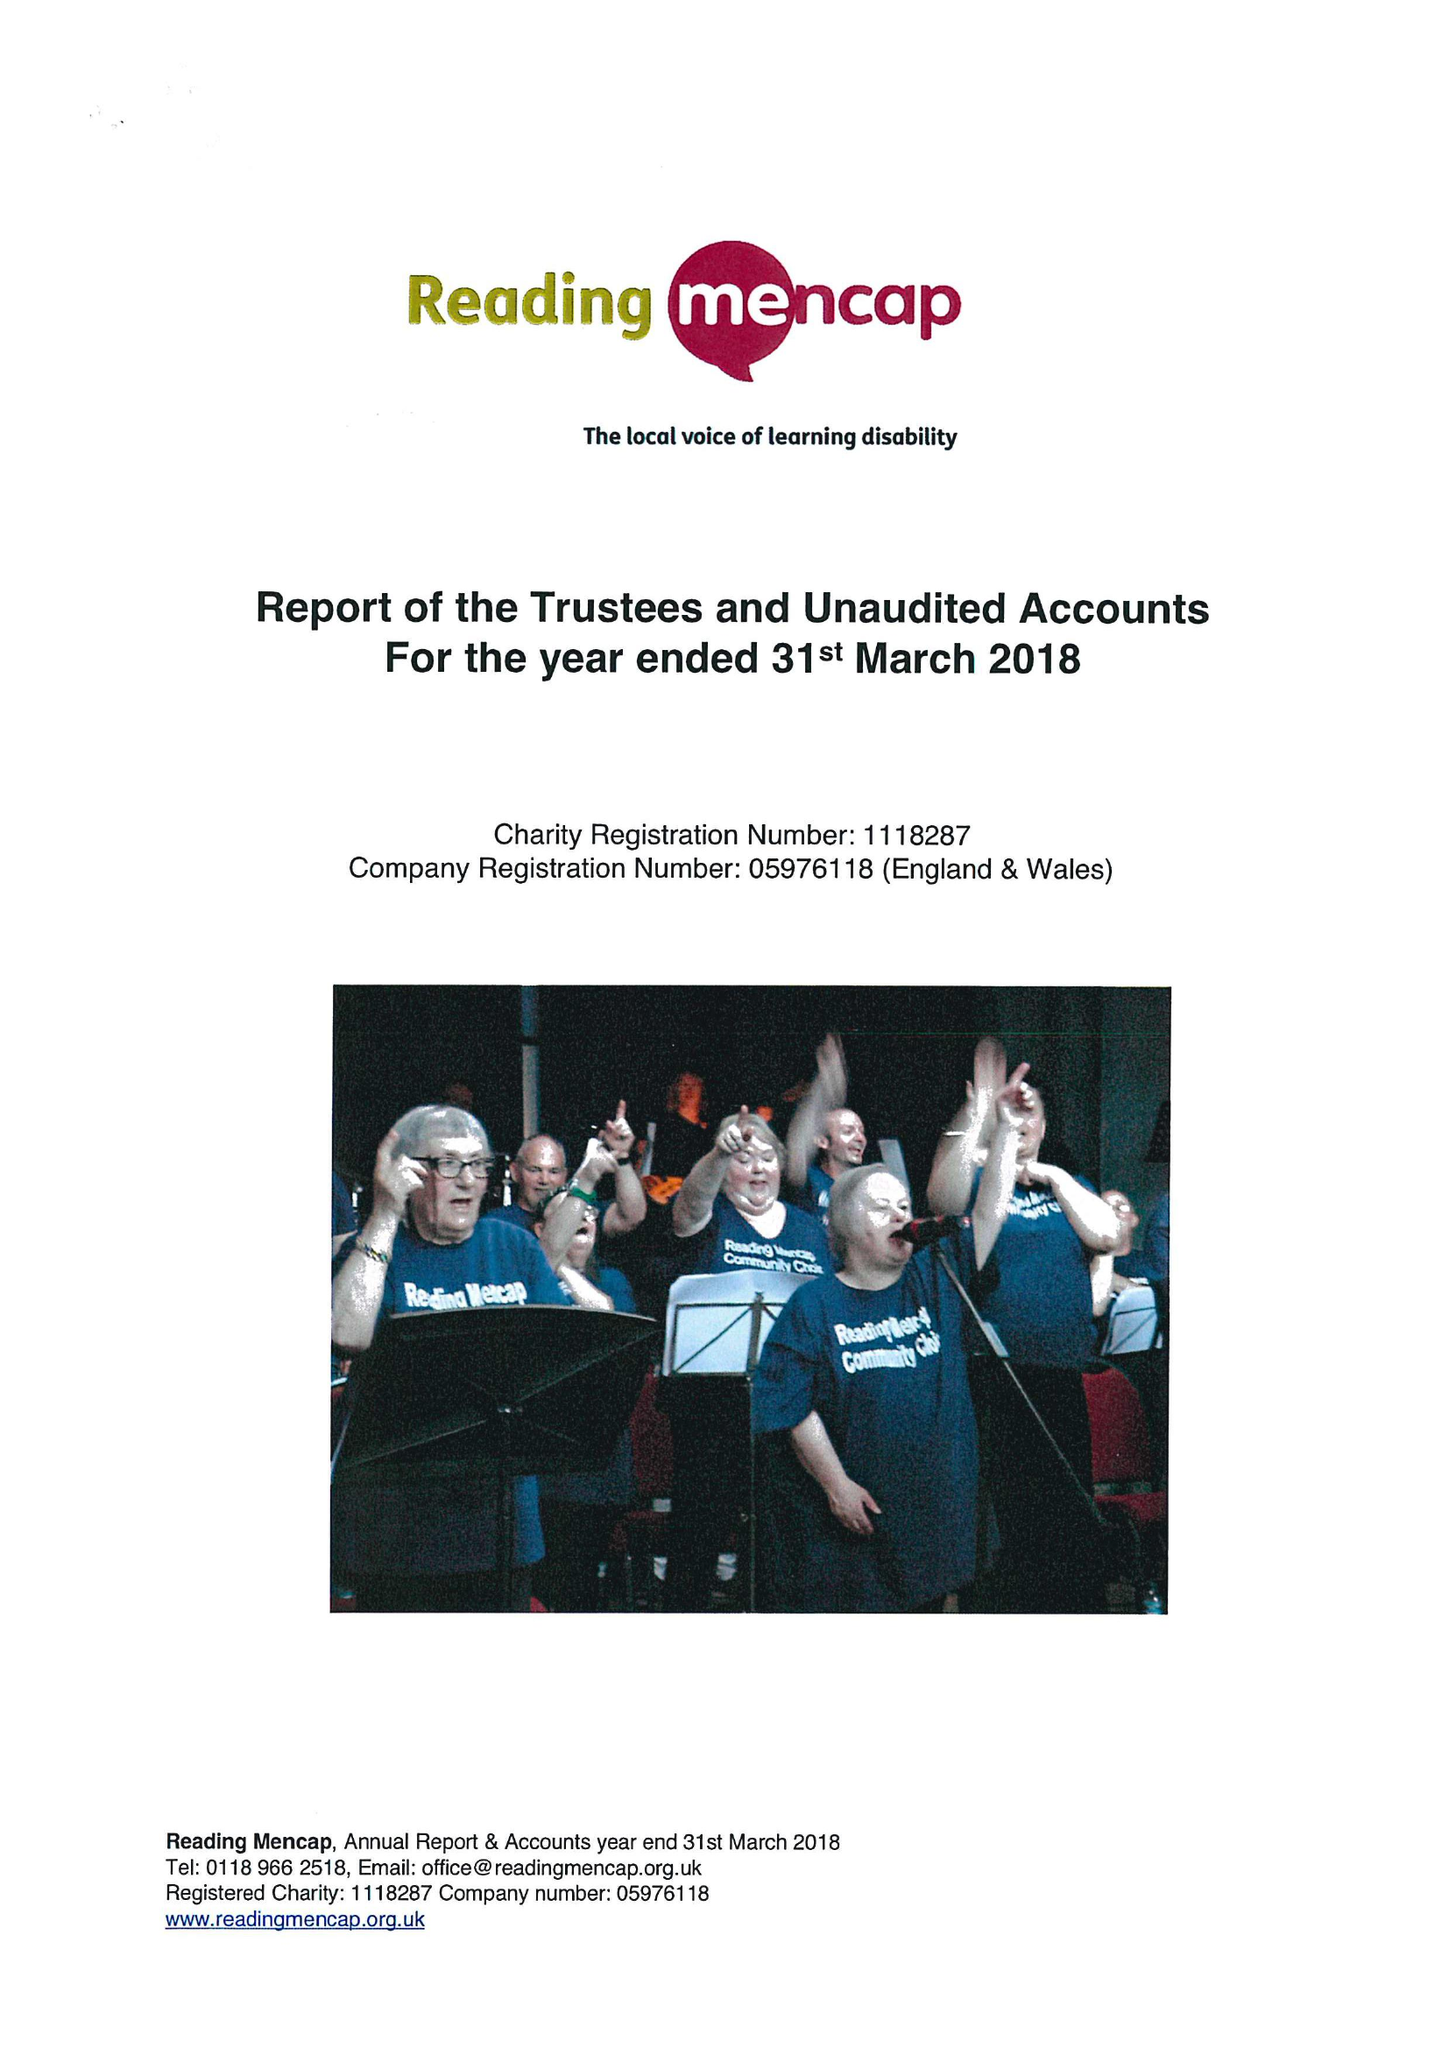What is the value for the income_annually_in_british_pounds?
Answer the question using a single word or phrase. 366266.00 